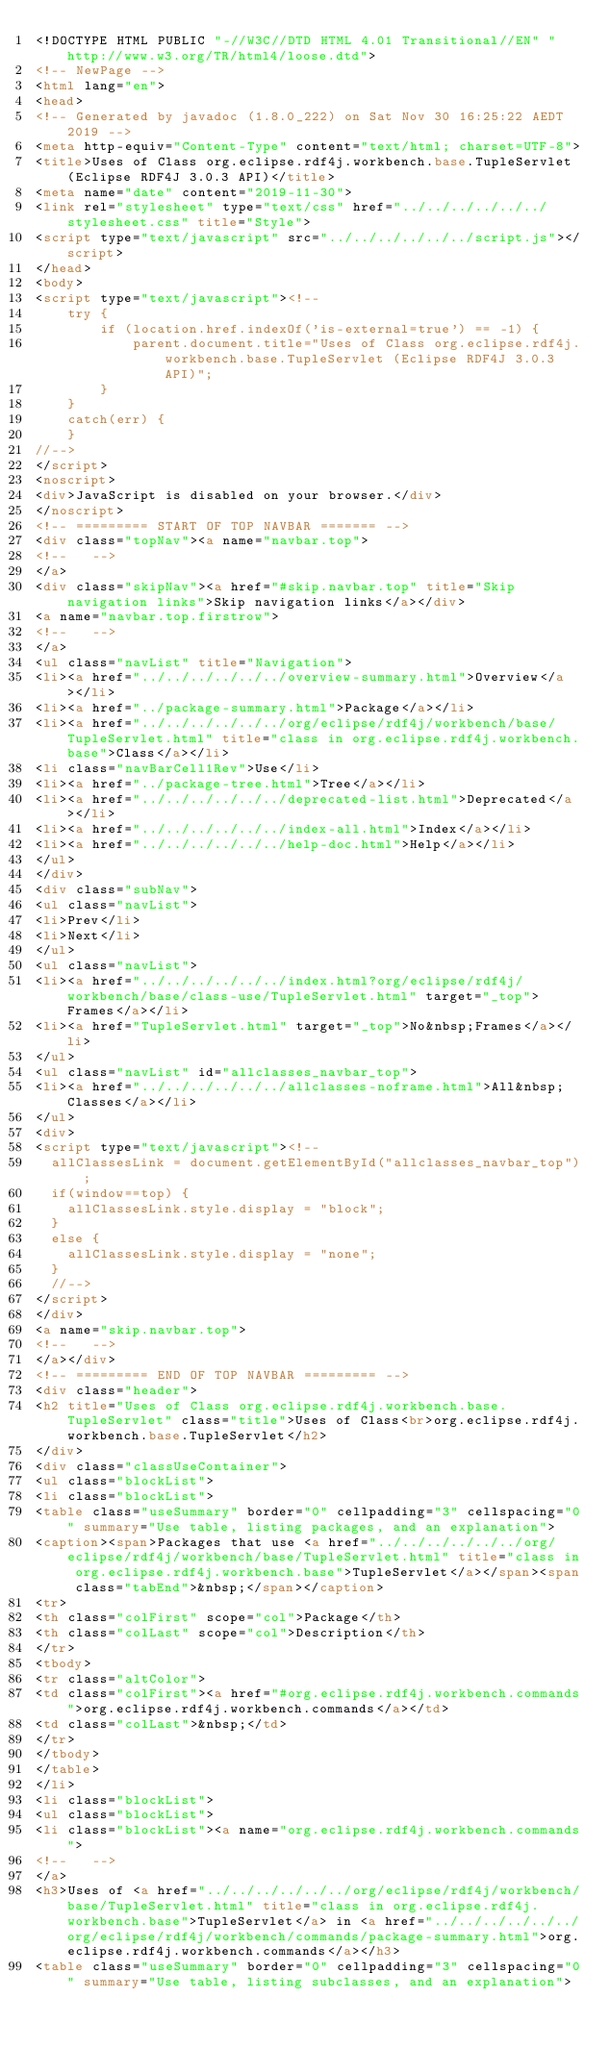Convert code to text. <code><loc_0><loc_0><loc_500><loc_500><_HTML_><!DOCTYPE HTML PUBLIC "-//W3C//DTD HTML 4.01 Transitional//EN" "http://www.w3.org/TR/html4/loose.dtd">
<!-- NewPage -->
<html lang="en">
<head>
<!-- Generated by javadoc (1.8.0_222) on Sat Nov 30 16:25:22 AEDT 2019 -->
<meta http-equiv="Content-Type" content="text/html; charset=UTF-8">
<title>Uses of Class org.eclipse.rdf4j.workbench.base.TupleServlet (Eclipse RDF4J 3.0.3 API)</title>
<meta name="date" content="2019-11-30">
<link rel="stylesheet" type="text/css" href="../../../../../../stylesheet.css" title="Style">
<script type="text/javascript" src="../../../../../../script.js"></script>
</head>
<body>
<script type="text/javascript"><!--
    try {
        if (location.href.indexOf('is-external=true') == -1) {
            parent.document.title="Uses of Class org.eclipse.rdf4j.workbench.base.TupleServlet (Eclipse RDF4J 3.0.3 API)";
        }
    }
    catch(err) {
    }
//-->
</script>
<noscript>
<div>JavaScript is disabled on your browser.</div>
</noscript>
<!-- ========= START OF TOP NAVBAR ======= -->
<div class="topNav"><a name="navbar.top">
<!--   -->
</a>
<div class="skipNav"><a href="#skip.navbar.top" title="Skip navigation links">Skip navigation links</a></div>
<a name="navbar.top.firstrow">
<!--   -->
</a>
<ul class="navList" title="Navigation">
<li><a href="../../../../../../overview-summary.html">Overview</a></li>
<li><a href="../package-summary.html">Package</a></li>
<li><a href="../../../../../../org/eclipse/rdf4j/workbench/base/TupleServlet.html" title="class in org.eclipse.rdf4j.workbench.base">Class</a></li>
<li class="navBarCell1Rev">Use</li>
<li><a href="../package-tree.html">Tree</a></li>
<li><a href="../../../../../../deprecated-list.html">Deprecated</a></li>
<li><a href="../../../../../../index-all.html">Index</a></li>
<li><a href="../../../../../../help-doc.html">Help</a></li>
</ul>
</div>
<div class="subNav">
<ul class="navList">
<li>Prev</li>
<li>Next</li>
</ul>
<ul class="navList">
<li><a href="../../../../../../index.html?org/eclipse/rdf4j/workbench/base/class-use/TupleServlet.html" target="_top">Frames</a></li>
<li><a href="TupleServlet.html" target="_top">No&nbsp;Frames</a></li>
</ul>
<ul class="navList" id="allclasses_navbar_top">
<li><a href="../../../../../../allclasses-noframe.html">All&nbsp;Classes</a></li>
</ul>
<div>
<script type="text/javascript"><!--
  allClassesLink = document.getElementById("allclasses_navbar_top");
  if(window==top) {
    allClassesLink.style.display = "block";
  }
  else {
    allClassesLink.style.display = "none";
  }
  //-->
</script>
</div>
<a name="skip.navbar.top">
<!--   -->
</a></div>
<!-- ========= END OF TOP NAVBAR ========= -->
<div class="header">
<h2 title="Uses of Class org.eclipse.rdf4j.workbench.base.TupleServlet" class="title">Uses of Class<br>org.eclipse.rdf4j.workbench.base.TupleServlet</h2>
</div>
<div class="classUseContainer">
<ul class="blockList">
<li class="blockList">
<table class="useSummary" border="0" cellpadding="3" cellspacing="0" summary="Use table, listing packages, and an explanation">
<caption><span>Packages that use <a href="../../../../../../org/eclipse/rdf4j/workbench/base/TupleServlet.html" title="class in org.eclipse.rdf4j.workbench.base">TupleServlet</a></span><span class="tabEnd">&nbsp;</span></caption>
<tr>
<th class="colFirst" scope="col">Package</th>
<th class="colLast" scope="col">Description</th>
</tr>
<tbody>
<tr class="altColor">
<td class="colFirst"><a href="#org.eclipse.rdf4j.workbench.commands">org.eclipse.rdf4j.workbench.commands</a></td>
<td class="colLast">&nbsp;</td>
</tr>
</tbody>
</table>
</li>
<li class="blockList">
<ul class="blockList">
<li class="blockList"><a name="org.eclipse.rdf4j.workbench.commands">
<!--   -->
</a>
<h3>Uses of <a href="../../../../../../org/eclipse/rdf4j/workbench/base/TupleServlet.html" title="class in org.eclipse.rdf4j.workbench.base">TupleServlet</a> in <a href="../../../../../../org/eclipse/rdf4j/workbench/commands/package-summary.html">org.eclipse.rdf4j.workbench.commands</a></h3>
<table class="useSummary" border="0" cellpadding="3" cellspacing="0" summary="Use table, listing subclasses, and an explanation"></code> 